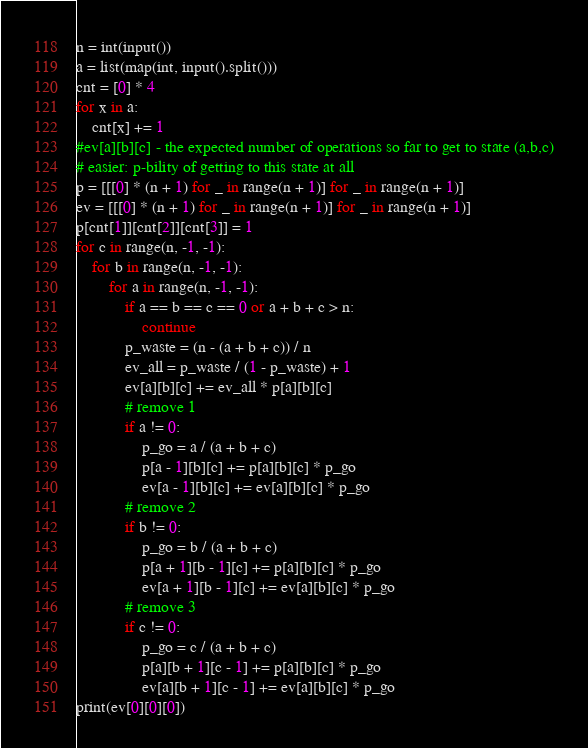Convert code to text. <code><loc_0><loc_0><loc_500><loc_500><_Python_>n = int(input())
a = list(map(int, input().split()))
cnt = [0] * 4
for x in a:
    cnt[x] += 1
#ev[a][b][c] - the expected number of operations so far to get to state (a,b,c)
# easier: p-bility of getting to this state at all
p = [[[0] * (n + 1) for _ in range(n + 1)] for _ in range(n + 1)]
ev = [[[0] * (n + 1) for _ in range(n + 1)] for _ in range(n + 1)]
p[cnt[1]][cnt[2]][cnt[3]] = 1
for c in range(n, -1, -1):
    for b in range(n, -1, -1):
        for a in range(n, -1, -1):
            if a == b == c == 0 or a + b + c > n:
                continue
            p_waste = (n - (a + b + c)) / n
            ev_all = p_waste / (1 - p_waste) + 1
            ev[a][b][c] += ev_all * p[a][b][c]
            # remove 1
            if a != 0:
                p_go = a / (a + b + c)
                p[a - 1][b][c] += p[a][b][c] * p_go
                ev[a - 1][b][c] += ev[a][b][c] * p_go
            # remove 2
            if b != 0:
                p_go = b / (a + b + c)
                p[a + 1][b - 1][c] += p[a][b][c] * p_go
                ev[a + 1][b - 1][c] += ev[a][b][c] * p_go
            # remove 3
            if c != 0:
                p_go = c / (a + b + c)
                p[a][b + 1][c - 1] += p[a][b][c] * p_go
                ev[a][b + 1][c - 1] += ev[a][b][c] * p_go
print(ev[0][0][0])</code> 